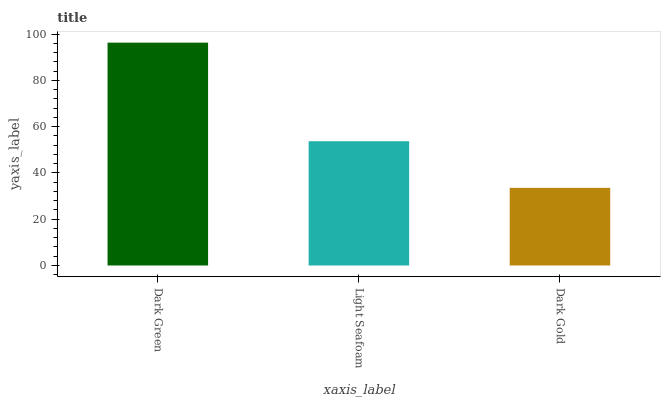Is Dark Gold the minimum?
Answer yes or no. Yes. Is Dark Green the maximum?
Answer yes or no. Yes. Is Light Seafoam the minimum?
Answer yes or no. No. Is Light Seafoam the maximum?
Answer yes or no. No. Is Dark Green greater than Light Seafoam?
Answer yes or no. Yes. Is Light Seafoam less than Dark Green?
Answer yes or no. Yes. Is Light Seafoam greater than Dark Green?
Answer yes or no. No. Is Dark Green less than Light Seafoam?
Answer yes or no. No. Is Light Seafoam the high median?
Answer yes or no. Yes. Is Light Seafoam the low median?
Answer yes or no. Yes. Is Dark Gold the high median?
Answer yes or no. No. Is Dark Green the low median?
Answer yes or no. No. 